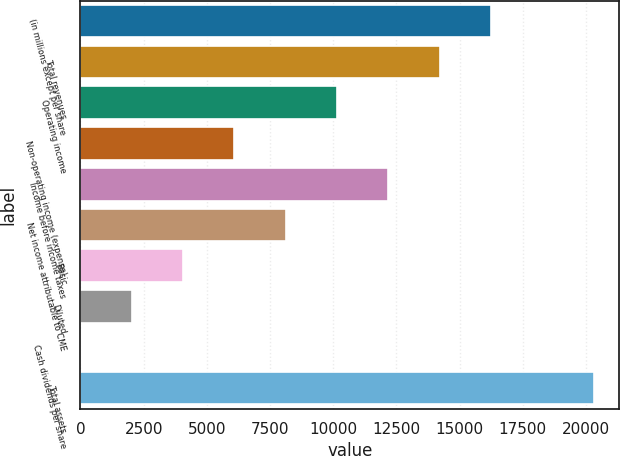Convert chart. <chart><loc_0><loc_0><loc_500><loc_500><bar_chart><fcel>(in millions except per share<fcel>Total revenues<fcel>Operating income<fcel>Non-operating income (expense)<fcel>Income before income taxes<fcel>Net income attributable to CME<fcel>Basic<fcel>Diluted<fcel>Cash dividends per share<fcel>Total assets<nl><fcel>16245.7<fcel>14215.4<fcel>10154.8<fcel>6094.28<fcel>12185.1<fcel>8124.56<fcel>4064<fcel>2033.72<fcel>3.44<fcel>20306.2<nl></chart> 